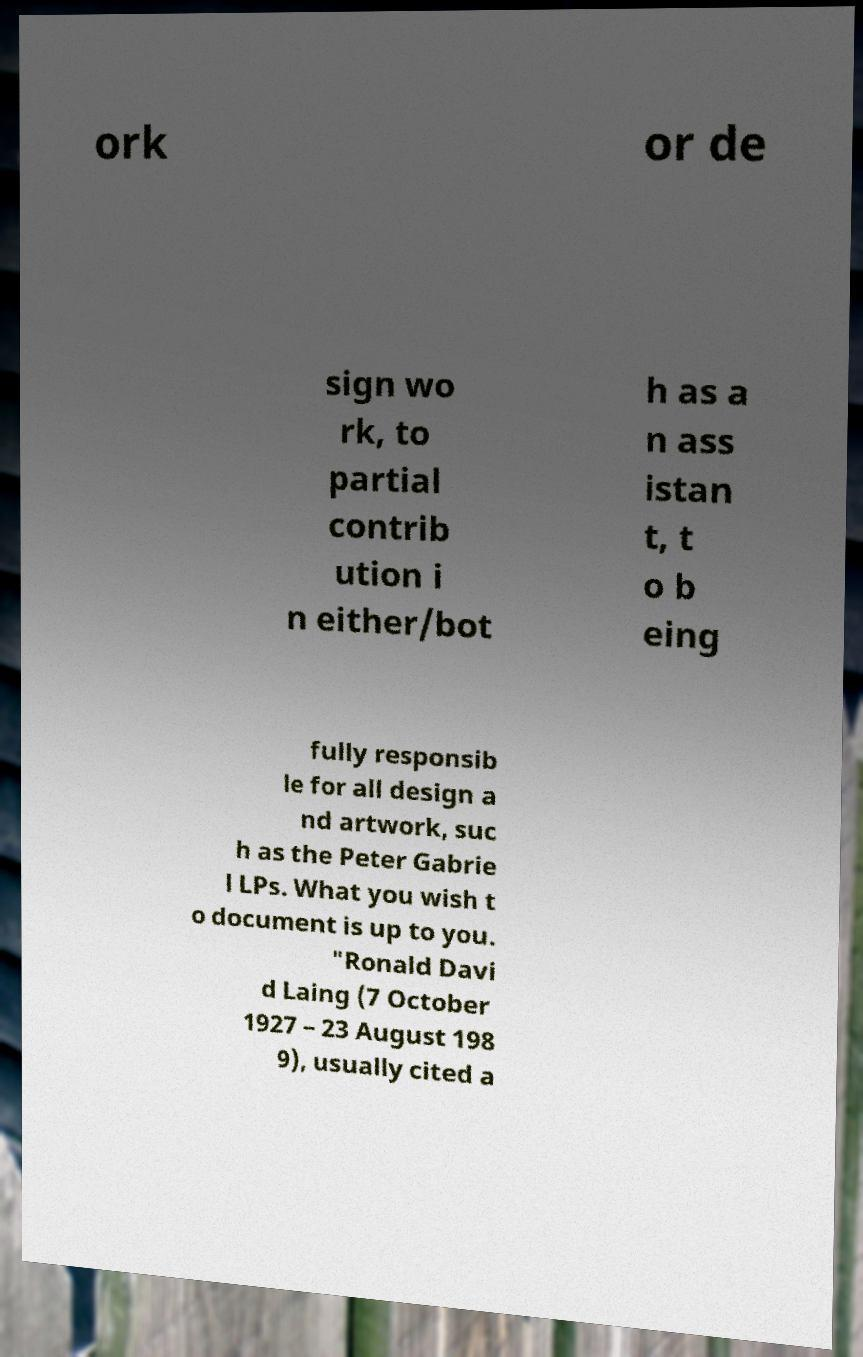Please identify and transcribe the text found in this image. ork or de sign wo rk, to partial contrib ution i n either/bot h as a n ass istan t, t o b eing fully responsib le for all design a nd artwork, suc h as the Peter Gabrie l LPs. What you wish t o document is up to you. "Ronald Davi d Laing (7 October 1927 – 23 August 198 9), usually cited a 